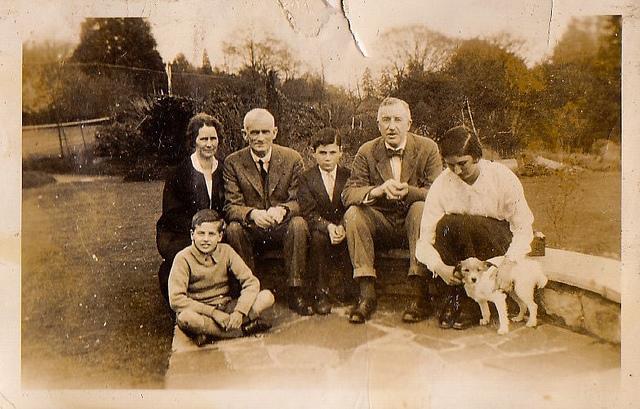What is the likely relationship of these people?
Answer briefly. Family. What the people sitting on?
Short answer required. Wall. How many people are wearing ties?
Quick response, please. 2. Is this photo more or less than 20 years old?
Give a very brief answer. More. 